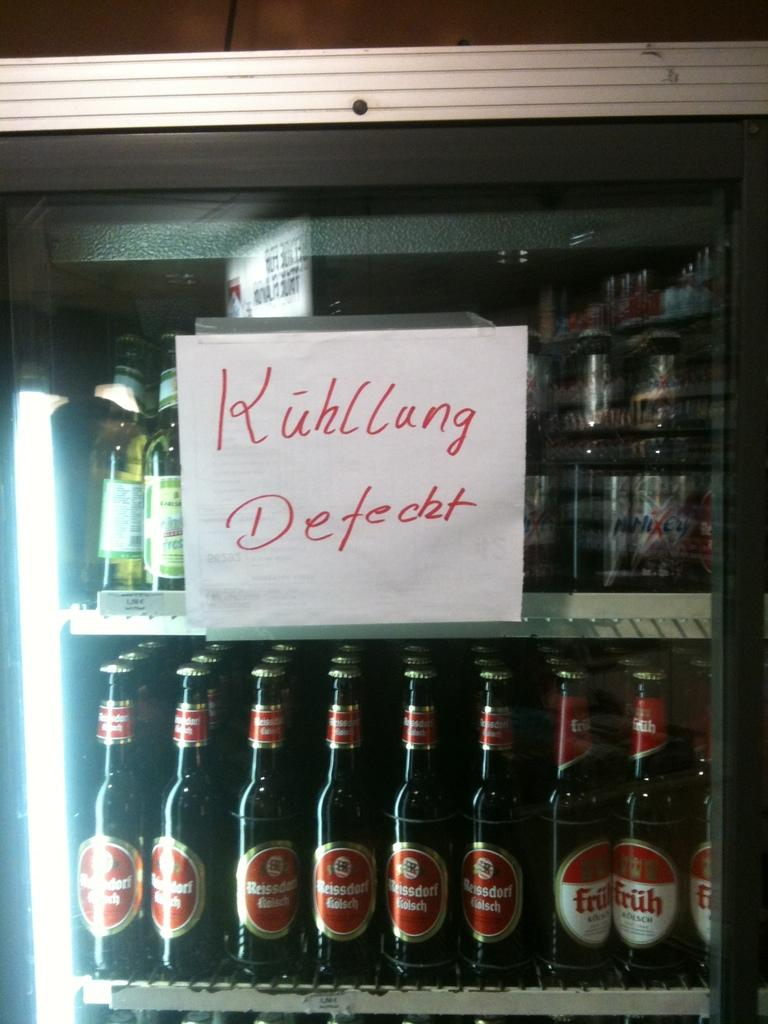<image>
Render a clear and concise summary of the photo. Mini fridge full of beers on top and bottom rack 